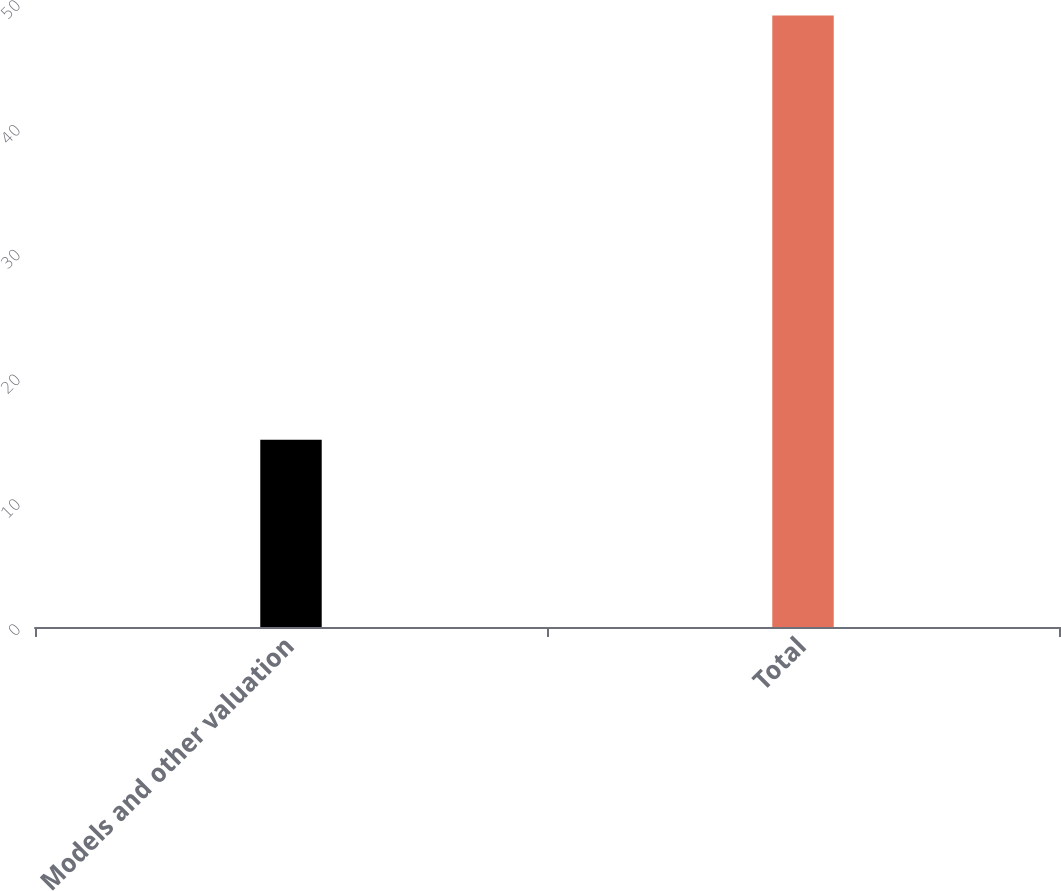Convert chart. <chart><loc_0><loc_0><loc_500><loc_500><bar_chart><fcel>Models and other valuation<fcel>Total<nl><fcel>15<fcel>49<nl></chart> 